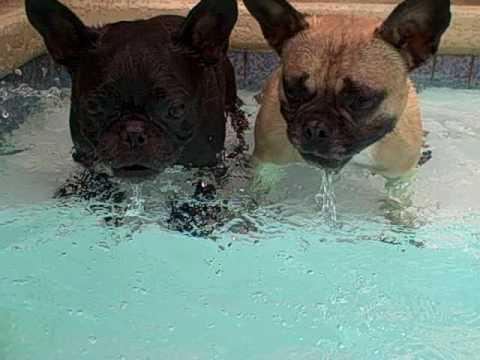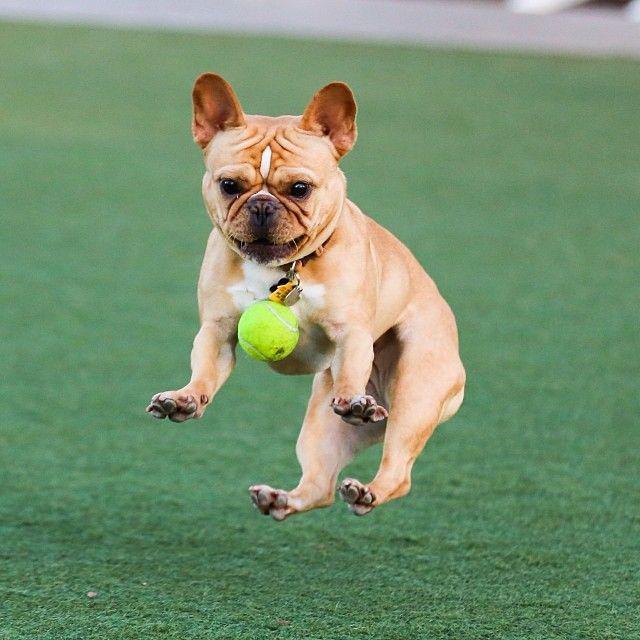The first image is the image on the left, the second image is the image on the right. Evaluate the accuracy of this statement regarding the images: "An image shows a tennis ball in front of one french bulldog, but not in contact with it.". Is it true? Answer yes or no. Yes. The first image is the image on the left, the second image is the image on the right. Analyze the images presented: Is the assertion "The left image includes a dog playing with a tennis ball." valid? Answer yes or no. No. 